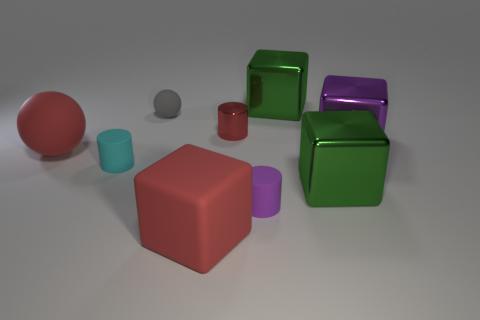Subtract 1 blocks. How many blocks are left? 3 Add 1 big metal blocks. How many objects exist? 10 Subtract all balls. How many objects are left? 7 Subtract 0 gray cubes. How many objects are left? 9 Subtract all big yellow metallic spheres. Subtract all small metallic things. How many objects are left? 8 Add 4 red matte objects. How many red matte objects are left? 6 Add 7 rubber cylinders. How many rubber cylinders exist? 9 